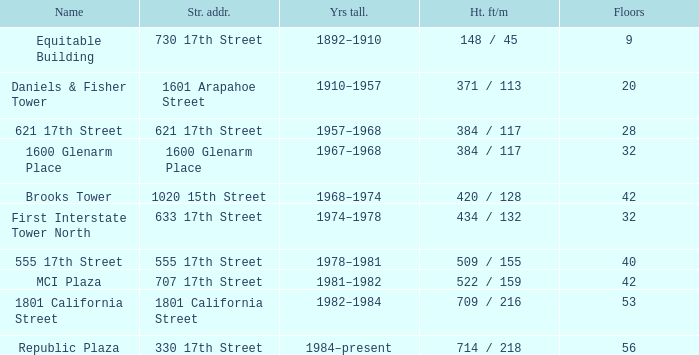What is the height of a 40-floor building? 509 / 155. 